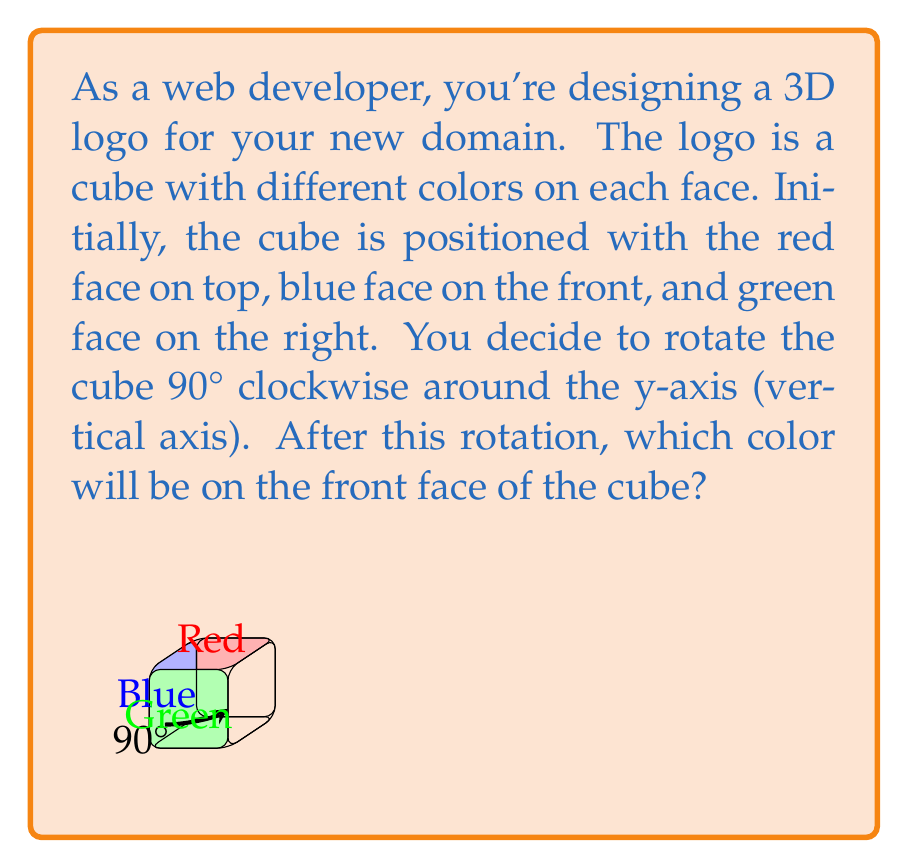Give your solution to this math problem. Let's approach this step-by-step:

1. Initial orientation:
   - Top face: Red
   - Front face: Blue
   - Right face: Green

2. The rotation is 90° clockwise around the y-axis (vertical axis). This means:
   - The top (red) and bottom faces will remain in their positions.
   - The front face will rotate to become the left face.
   - The right face will rotate to become the front face.
   - The back face will rotate to become the right face.
   - The left face will rotate to become the back face.

3. We can visualize this rotation mathematically using a rotation matrix:

   $$R_y(90°) = \begin{bmatrix}
   \cos(90°) & 0 & \sin(90°) \\
   0 & 1 & 0 \\
   -\sin(90°) & 0 & \cos(90°)
   \end{bmatrix} = \begin{bmatrix}
   0 & 0 & 1 \\
   0 & 1 & 0 \\
   -1 & 0 & 0
   \end{bmatrix}$$

4. Applying this rotation to the cube:
   - The point $(0,0,1)$ (front face) becomes $(-1,0,0)$ (left face)
   - The point $(1,0,0)$ (right face) becomes $(0,0,1)$ (front face)

5. Therefore, after the rotation, the face that was initially on the right (green) will now be on the front.
Answer: Green 